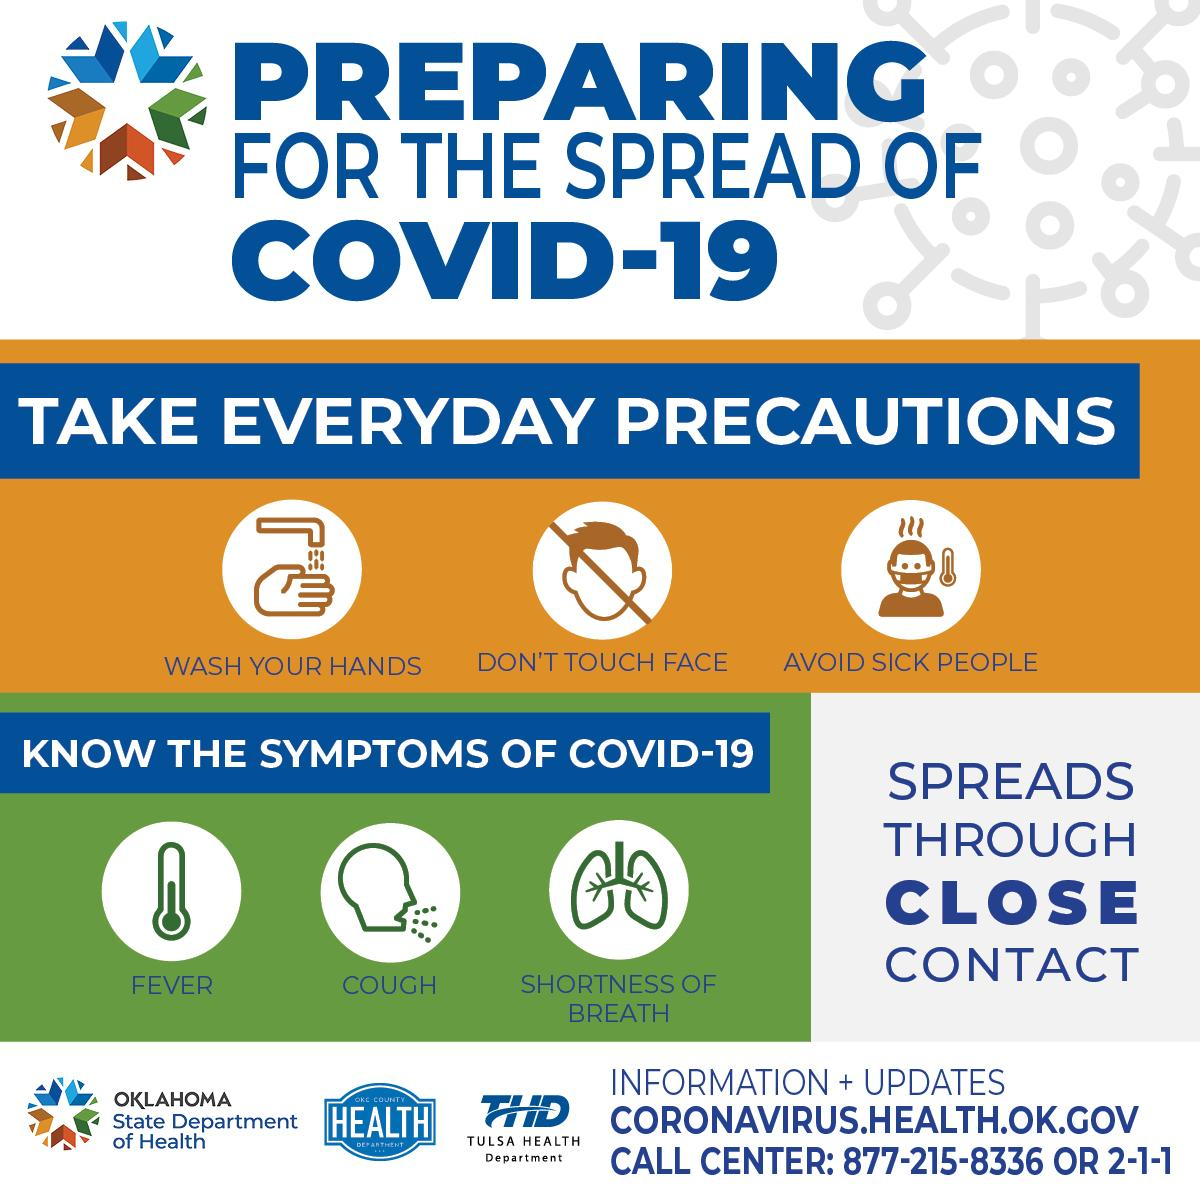Give some essential details in this illustration. The symptoms of COVID-19, in addition to fever and shortness of breath, may include a persistent cough. The precautionary measures to prevent the spread of coronavirus, other than avoiding close contact with sick individuals and avoiding touching the face, include but are not limited to: 